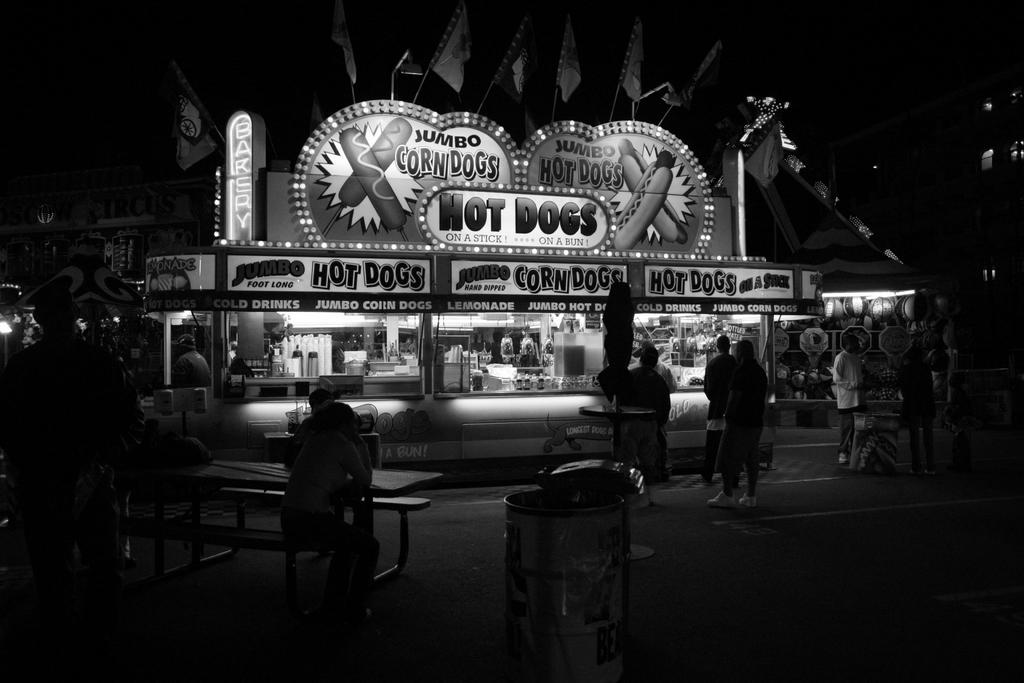<image>
Create a compact narrative representing the image presented. A photograph shows an old Hot Dog stand. 